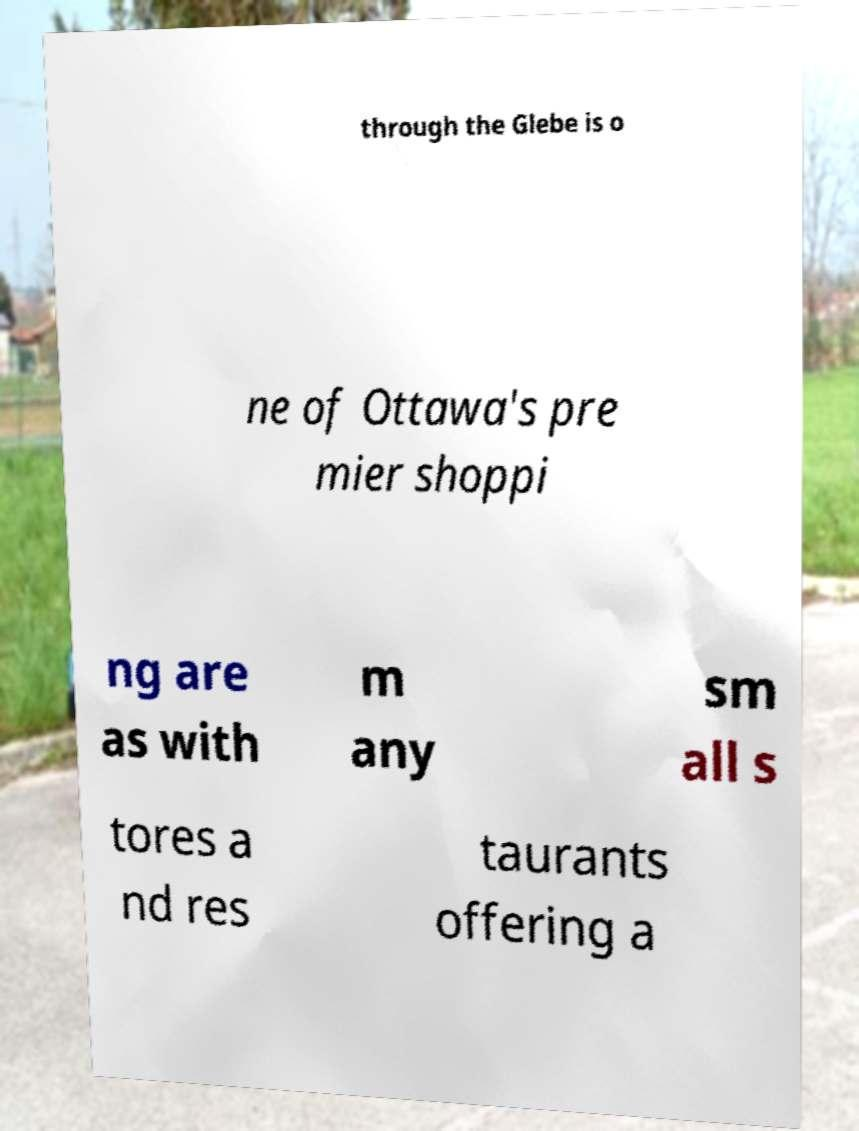Please identify and transcribe the text found in this image. through the Glebe is o ne of Ottawa's pre mier shoppi ng are as with m any sm all s tores a nd res taurants offering a 